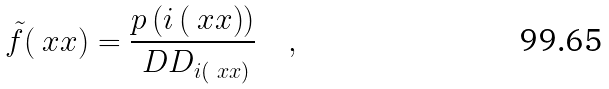Convert formula to latex. <formula><loc_0><loc_0><loc_500><loc_500>\tilde { f } ( \ x x ) = \frac { p \left ( i \left ( \ x x \right ) \right ) } { \ D D _ { i ( \ x x ) } } \quad ,</formula> 